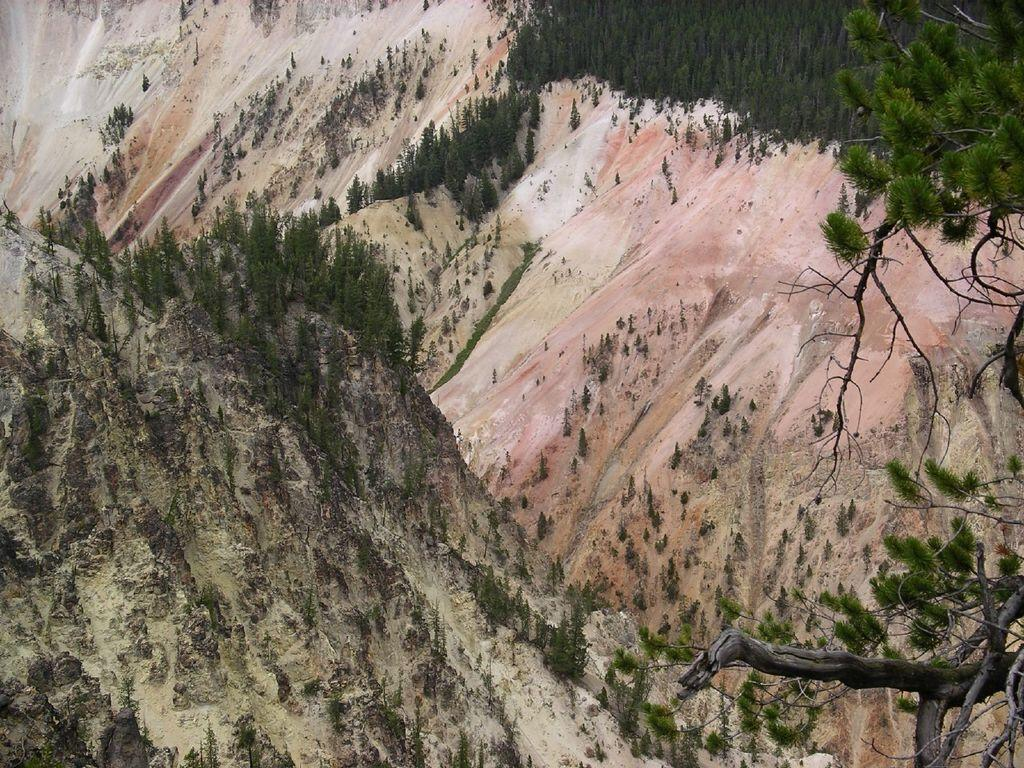What type of natural landform can be seen in the image? There are mountains in the image. What type of vegetation is present in the image? A: There are trees in the image. Where is the toothbrush located in the image? There is no toothbrush present in the image. What attempt is being made in the image? There is no attempt depicted in the image; it features mountains and trees. 